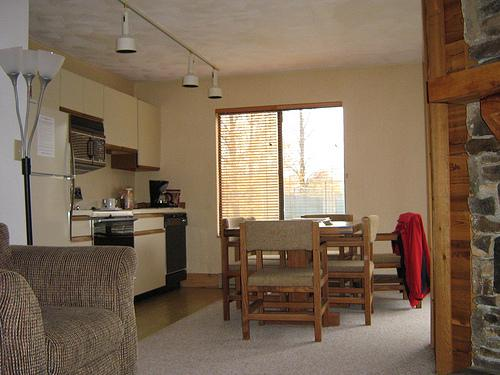Question: how is the day?
Choices:
A. Cloudy.
B. Sunny.
C. Bright.
D. Windy.
Answer with the letter. Answer: B Question: what is the color of the floor?
Choices:
A. Black.
B. Grey.
C. White.
D. Brown.
Answer with the letter. Answer: B Question: what is the color of the chair?
Choices:
A. Black.
B. White.
C. Blue.
D. Brown.
Answer with the letter. Answer: D 